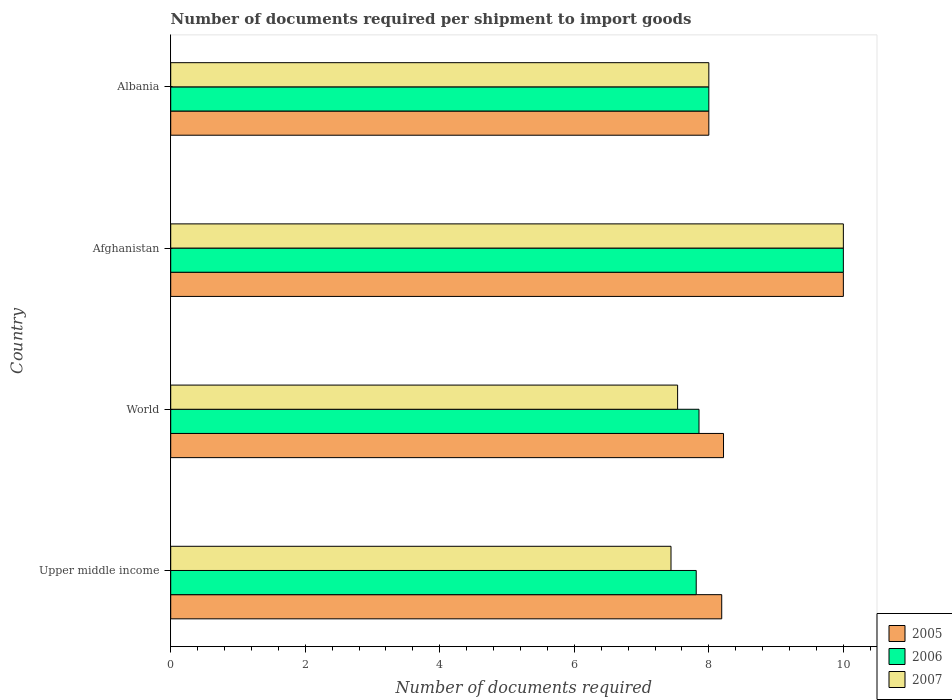Are the number of bars per tick equal to the number of legend labels?
Make the answer very short. Yes. Are the number of bars on each tick of the Y-axis equal?
Offer a very short reply. Yes. How many bars are there on the 3rd tick from the top?
Your response must be concise. 3. What is the label of the 3rd group of bars from the top?
Offer a very short reply. World. In how many cases, is the number of bars for a given country not equal to the number of legend labels?
Keep it short and to the point. 0. What is the number of documents required per shipment to import goods in 2006 in Albania?
Your response must be concise. 8. Across all countries, what is the minimum number of documents required per shipment to import goods in 2007?
Provide a short and direct response. 7.44. In which country was the number of documents required per shipment to import goods in 2006 maximum?
Give a very brief answer. Afghanistan. In which country was the number of documents required per shipment to import goods in 2005 minimum?
Your response must be concise. Albania. What is the total number of documents required per shipment to import goods in 2005 in the graph?
Your answer should be compact. 34.41. What is the difference between the number of documents required per shipment to import goods in 2007 in Albania and that in Upper middle income?
Ensure brevity in your answer.  0.56. What is the difference between the number of documents required per shipment to import goods in 2007 in Upper middle income and the number of documents required per shipment to import goods in 2006 in Afghanistan?
Offer a very short reply. -2.56. What is the average number of documents required per shipment to import goods in 2007 per country?
Your response must be concise. 8.24. What is the difference between the number of documents required per shipment to import goods in 2005 and number of documents required per shipment to import goods in 2006 in Upper middle income?
Keep it short and to the point. 0.38. Is the number of documents required per shipment to import goods in 2006 in Afghanistan less than that in World?
Offer a terse response. No. What is the difference between the highest and the lowest number of documents required per shipment to import goods in 2006?
Provide a short and direct response. 2.19. In how many countries, is the number of documents required per shipment to import goods in 2006 greater than the average number of documents required per shipment to import goods in 2006 taken over all countries?
Ensure brevity in your answer.  1. Is the sum of the number of documents required per shipment to import goods in 2007 in Upper middle income and World greater than the maximum number of documents required per shipment to import goods in 2006 across all countries?
Provide a short and direct response. Yes. What does the 2nd bar from the bottom in Upper middle income represents?
Offer a very short reply. 2006. Does the graph contain any zero values?
Provide a short and direct response. No. How many legend labels are there?
Keep it short and to the point. 3. What is the title of the graph?
Provide a short and direct response. Number of documents required per shipment to import goods. Does "2010" appear as one of the legend labels in the graph?
Your answer should be very brief. No. What is the label or title of the X-axis?
Your answer should be very brief. Number of documents required. What is the Number of documents required in 2005 in Upper middle income?
Your answer should be compact. 8.19. What is the Number of documents required of 2006 in Upper middle income?
Your response must be concise. 7.81. What is the Number of documents required in 2007 in Upper middle income?
Your answer should be very brief. 7.44. What is the Number of documents required of 2005 in World?
Your response must be concise. 8.22. What is the Number of documents required in 2006 in World?
Offer a terse response. 7.85. What is the Number of documents required in 2007 in World?
Make the answer very short. 7.54. What is the Number of documents required of 2007 in Afghanistan?
Your answer should be very brief. 10. What is the Number of documents required of 2005 in Albania?
Give a very brief answer. 8. What is the Number of documents required of 2007 in Albania?
Offer a very short reply. 8. Across all countries, what is the maximum Number of documents required of 2006?
Your answer should be compact. 10. Across all countries, what is the minimum Number of documents required of 2006?
Provide a succinct answer. 7.81. Across all countries, what is the minimum Number of documents required in 2007?
Your response must be concise. 7.44. What is the total Number of documents required of 2005 in the graph?
Your answer should be very brief. 34.41. What is the total Number of documents required in 2006 in the graph?
Offer a terse response. 33.67. What is the total Number of documents required in 2007 in the graph?
Ensure brevity in your answer.  32.97. What is the difference between the Number of documents required of 2005 in Upper middle income and that in World?
Ensure brevity in your answer.  -0.03. What is the difference between the Number of documents required of 2006 in Upper middle income and that in World?
Make the answer very short. -0.04. What is the difference between the Number of documents required of 2007 in Upper middle income and that in World?
Offer a terse response. -0.1. What is the difference between the Number of documents required in 2005 in Upper middle income and that in Afghanistan?
Ensure brevity in your answer.  -1.81. What is the difference between the Number of documents required of 2006 in Upper middle income and that in Afghanistan?
Offer a terse response. -2.19. What is the difference between the Number of documents required of 2007 in Upper middle income and that in Afghanistan?
Provide a succinct answer. -2.56. What is the difference between the Number of documents required of 2005 in Upper middle income and that in Albania?
Offer a very short reply. 0.19. What is the difference between the Number of documents required of 2006 in Upper middle income and that in Albania?
Offer a terse response. -0.19. What is the difference between the Number of documents required of 2007 in Upper middle income and that in Albania?
Ensure brevity in your answer.  -0.56. What is the difference between the Number of documents required of 2005 in World and that in Afghanistan?
Your answer should be very brief. -1.78. What is the difference between the Number of documents required of 2006 in World and that in Afghanistan?
Your answer should be very brief. -2.15. What is the difference between the Number of documents required in 2007 in World and that in Afghanistan?
Offer a terse response. -2.46. What is the difference between the Number of documents required in 2005 in World and that in Albania?
Make the answer very short. 0.22. What is the difference between the Number of documents required in 2006 in World and that in Albania?
Offer a terse response. -0.15. What is the difference between the Number of documents required in 2007 in World and that in Albania?
Your answer should be very brief. -0.46. What is the difference between the Number of documents required of 2007 in Afghanistan and that in Albania?
Provide a succinct answer. 2. What is the difference between the Number of documents required of 2005 in Upper middle income and the Number of documents required of 2006 in World?
Your response must be concise. 0.34. What is the difference between the Number of documents required of 2005 in Upper middle income and the Number of documents required of 2007 in World?
Your answer should be very brief. 0.66. What is the difference between the Number of documents required of 2006 in Upper middle income and the Number of documents required of 2007 in World?
Offer a very short reply. 0.28. What is the difference between the Number of documents required in 2005 in Upper middle income and the Number of documents required in 2006 in Afghanistan?
Your answer should be compact. -1.81. What is the difference between the Number of documents required in 2005 in Upper middle income and the Number of documents required in 2007 in Afghanistan?
Keep it short and to the point. -1.81. What is the difference between the Number of documents required in 2006 in Upper middle income and the Number of documents required in 2007 in Afghanistan?
Offer a very short reply. -2.19. What is the difference between the Number of documents required in 2005 in Upper middle income and the Number of documents required in 2006 in Albania?
Give a very brief answer. 0.19. What is the difference between the Number of documents required in 2005 in Upper middle income and the Number of documents required in 2007 in Albania?
Your answer should be very brief. 0.19. What is the difference between the Number of documents required in 2006 in Upper middle income and the Number of documents required in 2007 in Albania?
Your answer should be very brief. -0.19. What is the difference between the Number of documents required of 2005 in World and the Number of documents required of 2006 in Afghanistan?
Keep it short and to the point. -1.78. What is the difference between the Number of documents required of 2005 in World and the Number of documents required of 2007 in Afghanistan?
Your answer should be very brief. -1.78. What is the difference between the Number of documents required of 2006 in World and the Number of documents required of 2007 in Afghanistan?
Ensure brevity in your answer.  -2.15. What is the difference between the Number of documents required in 2005 in World and the Number of documents required in 2006 in Albania?
Offer a terse response. 0.22. What is the difference between the Number of documents required in 2005 in World and the Number of documents required in 2007 in Albania?
Your response must be concise. 0.22. What is the difference between the Number of documents required in 2006 in World and the Number of documents required in 2007 in Albania?
Provide a succinct answer. -0.15. What is the difference between the Number of documents required of 2005 in Afghanistan and the Number of documents required of 2007 in Albania?
Make the answer very short. 2. What is the difference between the Number of documents required in 2006 in Afghanistan and the Number of documents required in 2007 in Albania?
Offer a very short reply. 2. What is the average Number of documents required in 2005 per country?
Keep it short and to the point. 8.6. What is the average Number of documents required of 2006 per country?
Offer a terse response. 8.42. What is the average Number of documents required of 2007 per country?
Keep it short and to the point. 8.24. What is the difference between the Number of documents required of 2005 and Number of documents required of 2006 in Upper middle income?
Ensure brevity in your answer.  0.38. What is the difference between the Number of documents required of 2005 and Number of documents required of 2007 in Upper middle income?
Your response must be concise. 0.75. What is the difference between the Number of documents required of 2006 and Number of documents required of 2007 in Upper middle income?
Provide a short and direct response. 0.38. What is the difference between the Number of documents required of 2005 and Number of documents required of 2006 in World?
Offer a terse response. 0.36. What is the difference between the Number of documents required in 2005 and Number of documents required in 2007 in World?
Provide a short and direct response. 0.68. What is the difference between the Number of documents required in 2006 and Number of documents required in 2007 in World?
Give a very brief answer. 0.32. What is the difference between the Number of documents required in 2005 and Number of documents required in 2006 in Afghanistan?
Keep it short and to the point. 0. What is the difference between the Number of documents required in 2005 and Number of documents required in 2007 in Afghanistan?
Your answer should be very brief. 0. What is the difference between the Number of documents required of 2006 and Number of documents required of 2007 in Afghanistan?
Keep it short and to the point. 0. What is the difference between the Number of documents required in 2005 and Number of documents required in 2007 in Albania?
Keep it short and to the point. 0. What is the difference between the Number of documents required of 2006 and Number of documents required of 2007 in Albania?
Ensure brevity in your answer.  0. What is the ratio of the Number of documents required of 2005 in Upper middle income to that in World?
Make the answer very short. 1. What is the ratio of the Number of documents required in 2007 in Upper middle income to that in World?
Keep it short and to the point. 0.99. What is the ratio of the Number of documents required in 2005 in Upper middle income to that in Afghanistan?
Offer a terse response. 0.82. What is the ratio of the Number of documents required of 2006 in Upper middle income to that in Afghanistan?
Give a very brief answer. 0.78. What is the ratio of the Number of documents required in 2007 in Upper middle income to that in Afghanistan?
Your answer should be very brief. 0.74. What is the ratio of the Number of documents required of 2005 in Upper middle income to that in Albania?
Offer a very short reply. 1.02. What is the ratio of the Number of documents required of 2006 in Upper middle income to that in Albania?
Offer a very short reply. 0.98. What is the ratio of the Number of documents required in 2007 in Upper middle income to that in Albania?
Provide a succinct answer. 0.93. What is the ratio of the Number of documents required of 2005 in World to that in Afghanistan?
Your response must be concise. 0.82. What is the ratio of the Number of documents required in 2006 in World to that in Afghanistan?
Your answer should be very brief. 0.79. What is the ratio of the Number of documents required of 2007 in World to that in Afghanistan?
Offer a very short reply. 0.75. What is the ratio of the Number of documents required in 2005 in World to that in Albania?
Your answer should be compact. 1.03. What is the ratio of the Number of documents required in 2006 in World to that in Albania?
Make the answer very short. 0.98. What is the ratio of the Number of documents required in 2007 in World to that in Albania?
Ensure brevity in your answer.  0.94. What is the ratio of the Number of documents required in 2005 in Afghanistan to that in Albania?
Your answer should be very brief. 1.25. What is the ratio of the Number of documents required of 2007 in Afghanistan to that in Albania?
Provide a short and direct response. 1.25. What is the difference between the highest and the second highest Number of documents required in 2005?
Your answer should be compact. 1.78. What is the difference between the highest and the second highest Number of documents required of 2007?
Keep it short and to the point. 2. What is the difference between the highest and the lowest Number of documents required of 2006?
Make the answer very short. 2.19. What is the difference between the highest and the lowest Number of documents required of 2007?
Ensure brevity in your answer.  2.56. 